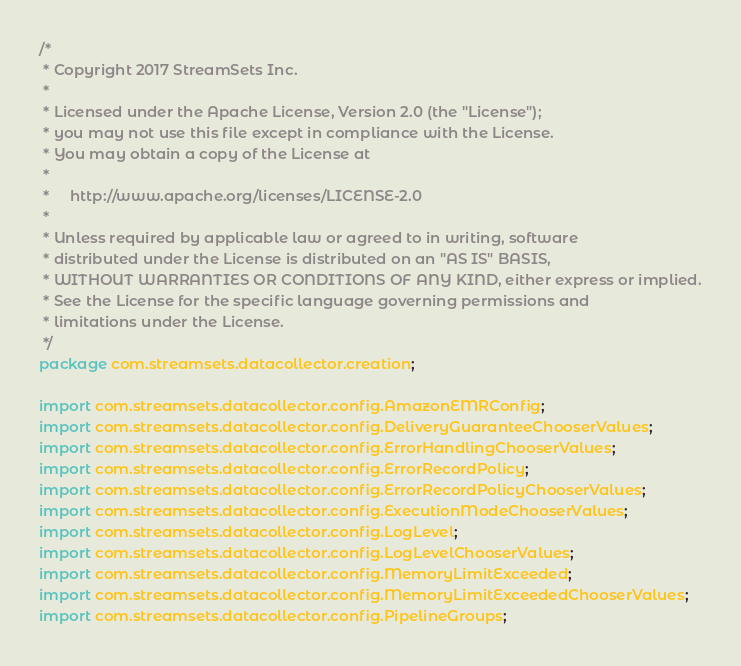<code> <loc_0><loc_0><loc_500><loc_500><_Java_>/*
 * Copyright 2017 StreamSets Inc.
 *
 * Licensed under the Apache License, Version 2.0 (the "License");
 * you may not use this file except in compliance with the License.
 * You may obtain a copy of the License at
 *
 *     http://www.apache.org/licenses/LICENSE-2.0
 *
 * Unless required by applicable law or agreed to in writing, software
 * distributed under the License is distributed on an "AS IS" BASIS,
 * WITHOUT WARRANTIES OR CONDITIONS OF ANY KIND, either express or implied.
 * See the License for the specific language governing permissions and
 * limitations under the License.
 */
package com.streamsets.datacollector.creation;

import com.streamsets.datacollector.config.AmazonEMRConfig;
import com.streamsets.datacollector.config.DeliveryGuaranteeChooserValues;
import com.streamsets.datacollector.config.ErrorHandlingChooserValues;
import com.streamsets.datacollector.config.ErrorRecordPolicy;
import com.streamsets.datacollector.config.ErrorRecordPolicyChooserValues;
import com.streamsets.datacollector.config.ExecutionModeChooserValues;
import com.streamsets.datacollector.config.LogLevel;
import com.streamsets.datacollector.config.LogLevelChooserValues;
import com.streamsets.datacollector.config.MemoryLimitExceeded;
import com.streamsets.datacollector.config.MemoryLimitExceededChooserValues;
import com.streamsets.datacollector.config.PipelineGroups;</code> 